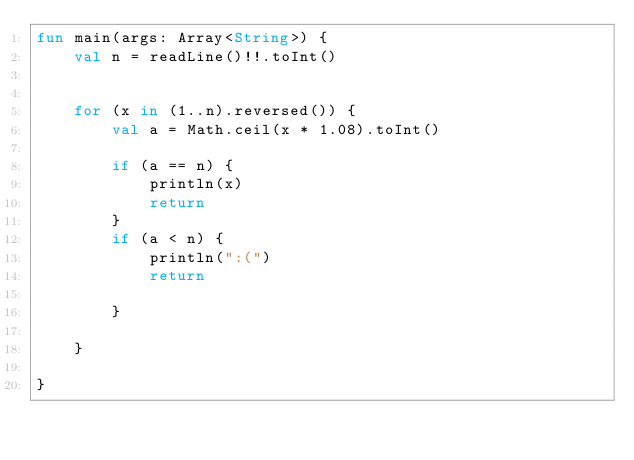<code> <loc_0><loc_0><loc_500><loc_500><_Kotlin_>fun main(args: Array<String>) {
    val n = readLine()!!.toInt()


    for (x in (1..n).reversed()) {
        val a = Math.ceil(x * 1.08).toInt()

        if (a == n) {
            println(x)
            return
        }
        if (a < n) {
            println(":(")
            return

        }

    }

}
</code> 